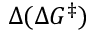<formula> <loc_0><loc_0><loc_500><loc_500>\Delta ( \Delta G ^ { \ddagger } )</formula> 